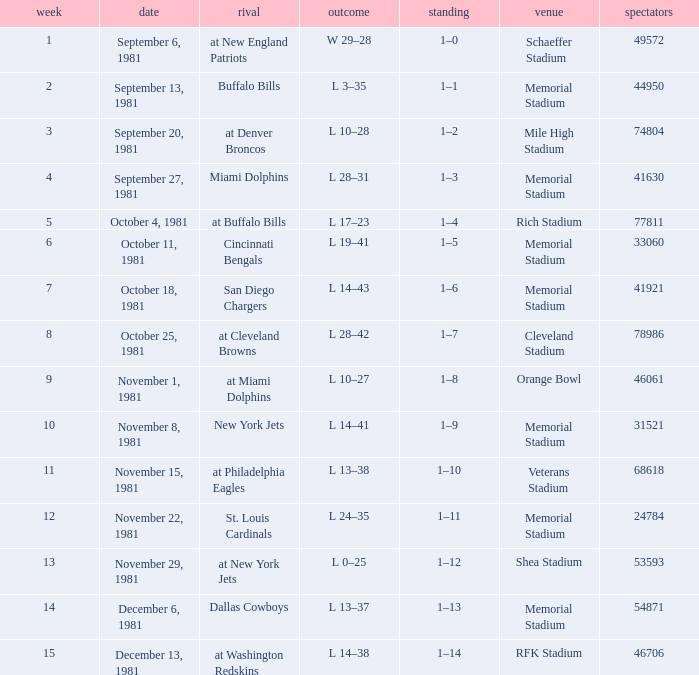When it is October 18, 1981 where is the game site? Memorial Stadium. 